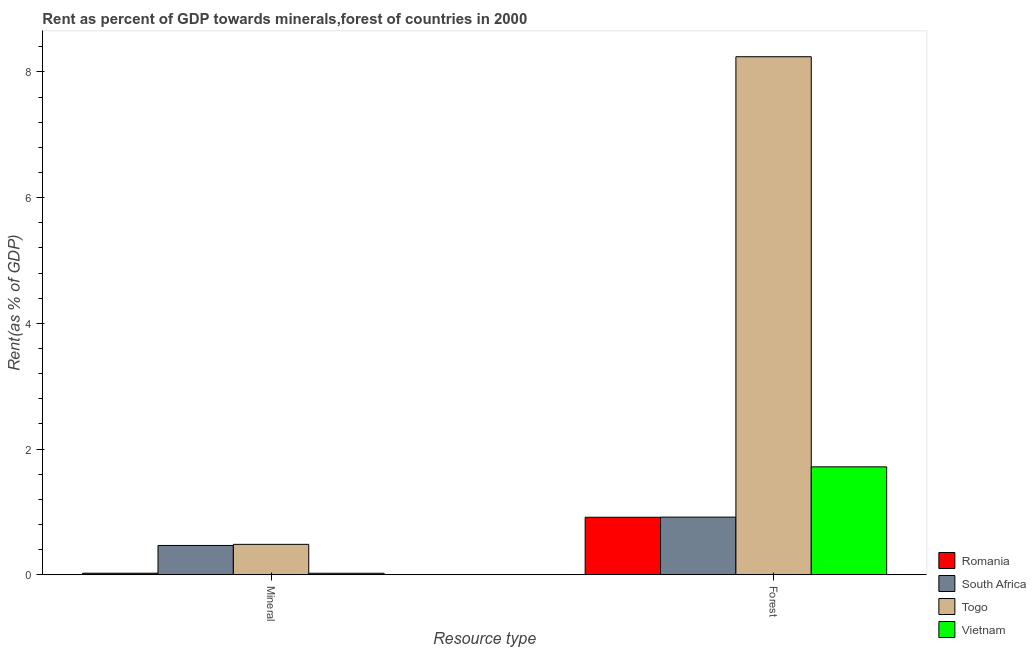How many different coloured bars are there?
Keep it short and to the point. 4. Are the number of bars per tick equal to the number of legend labels?
Make the answer very short. Yes. Are the number of bars on each tick of the X-axis equal?
Your answer should be very brief. Yes. What is the label of the 1st group of bars from the left?
Provide a short and direct response. Mineral. What is the forest rent in Vietnam?
Make the answer very short. 1.72. Across all countries, what is the maximum mineral rent?
Your answer should be very brief. 0.48. Across all countries, what is the minimum mineral rent?
Ensure brevity in your answer.  0.02. In which country was the forest rent maximum?
Provide a short and direct response. Togo. In which country was the mineral rent minimum?
Your answer should be compact. Vietnam. What is the total mineral rent in the graph?
Offer a terse response. 0.99. What is the difference between the forest rent in South Africa and that in Togo?
Provide a succinct answer. -7.33. What is the difference between the mineral rent in Romania and the forest rent in Vietnam?
Ensure brevity in your answer.  -1.69. What is the average forest rent per country?
Provide a short and direct response. 2.95. What is the difference between the mineral rent and forest rent in South Africa?
Give a very brief answer. -0.45. What is the ratio of the forest rent in South Africa to that in Togo?
Your answer should be compact. 0.11. What does the 3rd bar from the left in Mineral represents?
Provide a short and direct response. Togo. What does the 1st bar from the right in Forest represents?
Give a very brief answer. Vietnam. How many bars are there?
Keep it short and to the point. 8. Are all the bars in the graph horizontal?
Make the answer very short. No. Are the values on the major ticks of Y-axis written in scientific E-notation?
Give a very brief answer. No. Does the graph contain any zero values?
Offer a very short reply. No. Does the graph contain grids?
Keep it short and to the point. No. How many legend labels are there?
Your answer should be compact. 4. What is the title of the graph?
Offer a very short reply. Rent as percent of GDP towards minerals,forest of countries in 2000. What is the label or title of the X-axis?
Your response must be concise. Resource type. What is the label or title of the Y-axis?
Provide a succinct answer. Rent(as % of GDP). What is the Rent(as % of GDP) in Romania in Mineral?
Your answer should be very brief. 0.02. What is the Rent(as % of GDP) of South Africa in Mineral?
Give a very brief answer. 0.47. What is the Rent(as % of GDP) in Togo in Mineral?
Keep it short and to the point. 0.48. What is the Rent(as % of GDP) of Vietnam in Mineral?
Provide a succinct answer. 0.02. What is the Rent(as % of GDP) in Romania in Forest?
Provide a short and direct response. 0.91. What is the Rent(as % of GDP) in South Africa in Forest?
Provide a succinct answer. 0.92. What is the Rent(as % of GDP) in Togo in Forest?
Ensure brevity in your answer.  8.24. What is the Rent(as % of GDP) in Vietnam in Forest?
Offer a terse response. 1.72. Across all Resource type, what is the maximum Rent(as % of GDP) of Romania?
Ensure brevity in your answer.  0.91. Across all Resource type, what is the maximum Rent(as % of GDP) of South Africa?
Your answer should be very brief. 0.92. Across all Resource type, what is the maximum Rent(as % of GDP) in Togo?
Your answer should be very brief. 8.24. Across all Resource type, what is the maximum Rent(as % of GDP) of Vietnam?
Give a very brief answer. 1.72. Across all Resource type, what is the minimum Rent(as % of GDP) of Romania?
Give a very brief answer. 0.02. Across all Resource type, what is the minimum Rent(as % of GDP) in South Africa?
Ensure brevity in your answer.  0.47. Across all Resource type, what is the minimum Rent(as % of GDP) of Togo?
Offer a very short reply. 0.48. Across all Resource type, what is the minimum Rent(as % of GDP) of Vietnam?
Your answer should be very brief. 0.02. What is the total Rent(as % of GDP) in Romania in the graph?
Give a very brief answer. 0.94. What is the total Rent(as % of GDP) in South Africa in the graph?
Your answer should be very brief. 1.38. What is the total Rent(as % of GDP) in Togo in the graph?
Offer a terse response. 8.73. What is the total Rent(as % of GDP) of Vietnam in the graph?
Keep it short and to the point. 1.74. What is the difference between the Rent(as % of GDP) of Romania in Mineral and that in Forest?
Give a very brief answer. -0.89. What is the difference between the Rent(as % of GDP) of South Africa in Mineral and that in Forest?
Offer a very short reply. -0.45. What is the difference between the Rent(as % of GDP) of Togo in Mineral and that in Forest?
Provide a short and direct response. -7.76. What is the difference between the Rent(as % of GDP) of Vietnam in Mineral and that in Forest?
Ensure brevity in your answer.  -1.69. What is the difference between the Rent(as % of GDP) in Romania in Mineral and the Rent(as % of GDP) in South Africa in Forest?
Make the answer very short. -0.89. What is the difference between the Rent(as % of GDP) of Romania in Mineral and the Rent(as % of GDP) of Togo in Forest?
Your answer should be very brief. -8.22. What is the difference between the Rent(as % of GDP) in Romania in Mineral and the Rent(as % of GDP) in Vietnam in Forest?
Your answer should be very brief. -1.69. What is the difference between the Rent(as % of GDP) in South Africa in Mineral and the Rent(as % of GDP) in Togo in Forest?
Your answer should be compact. -7.78. What is the difference between the Rent(as % of GDP) in South Africa in Mineral and the Rent(as % of GDP) in Vietnam in Forest?
Your answer should be compact. -1.25. What is the difference between the Rent(as % of GDP) of Togo in Mineral and the Rent(as % of GDP) of Vietnam in Forest?
Your answer should be compact. -1.23. What is the average Rent(as % of GDP) in Romania per Resource type?
Ensure brevity in your answer.  0.47. What is the average Rent(as % of GDP) of South Africa per Resource type?
Offer a very short reply. 0.69. What is the average Rent(as % of GDP) of Togo per Resource type?
Make the answer very short. 4.36. What is the average Rent(as % of GDP) in Vietnam per Resource type?
Give a very brief answer. 0.87. What is the difference between the Rent(as % of GDP) in Romania and Rent(as % of GDP) in South Africa in Mineral?
Keep it short and to the point. -0.44. What is the difference between the Rent(as % of GDP) of Romania and Rent(as % of GDP) of Togo in Mineral?
Offer a very short reply. -0.46. What is the difference between the Rent(as % of GDP) in Romania and Rent(as % of GDP) in Vietnam in Mineral?
Your answer should be compact. 0. What is the difference between the Rent(as % of GDP) in South Africa and Rent(as % of GDP) in Togo in Mineral?
Provide a short and direct response. -0.02. What is the difference between the Rent(as % of GDP) in South Africa and Rent(as % of GDP) in Vietnam in Mineral?
Your answer should be very brief. 0.44. What is the difference between the Rent(as % of GDP) of Togo and Rent(as % of GDP) of Vietnam in Mineral?
Make the answer very short. 0.46. What is the difference between the Rent(as % of GDP) in Romania and Rent(as % of GDP) in South Africa in Forest?
Your response must be concise. -0. What is the difference between the Rent(as % of GDP) in Romania and Rent(as % of GDP) in Togo in Forest?
Offer a terse response. -7.33. What is the difference between the Rent(as % of GDP) of Romania and Rent(as % of GDP) of Vietnam in Forest?
Keep it short and to the point. -0.8. What is the difference between the Rent(as % of GDP) of South Africa and Rent(as % of GDP) of Togo in Forest?
Keep it short and to the point. -7.33. What is the difference between the Rent(as % of GDP) in South Africa and Rent(as % of GDP) in Vietnam in Forest?
Give a very brief answer. -0.8. What is the difference between the Rent(as % of GDP) of Togo and Rent(as % of GDP) of Vietnam in Forest?
Offer a terse response. 6.53. What is the ratio of the Rent(as % of GDP) of Romania in Mineral to that in Forest?
Your response must be concise. 0.03. What is the ratio of the Rent(as % of GDP) of South Africa in Mineral to that in Forest?
Provide a succinct answer. 0.51. What is the ratio of the Rent(as % of GDP) of Togo in Mineral to that in Forest?
Your response must be concise. 0.06. What is the ratio of the Rent(as % of GDP) in Vietnam in Mineral to that in Forest?
Your answer should be compact. 0.01. What is the difference between the highest and the second highest Rent(as % of GDP) in Romania?
Ensure brevity in your answer.  0.89. What is the difference between the highest and the second highest Rent(as % of GDP) in South Africa?
Ensure brevity in your answer.  0.45. What is the difference between the highest and the second highest Rent(as % of GDP) of Togo?
Offer a very short reply. 7.76. What is the difference between the highest and the second highest Rent(as % of GDP) of Vietnam?
Offer a terse response. 1.69. What is the difference between the highest and the lowest Rent(as % of GDP) of Romania?
Offer a very short reply. 0.89. What is the difference between the highest and the lowest Rent(as % of GDP) of South Africa?
Provide a short and direct response. 0.45. What is the difference between the highest and the lowest Rent(as % of GDP) of Togo?
Offer a terse response. 7.76. What is the difference between the highest and the lowest Rent(as % of GDP) in Vietnam?
Your answer should be very brief. 1.69. 